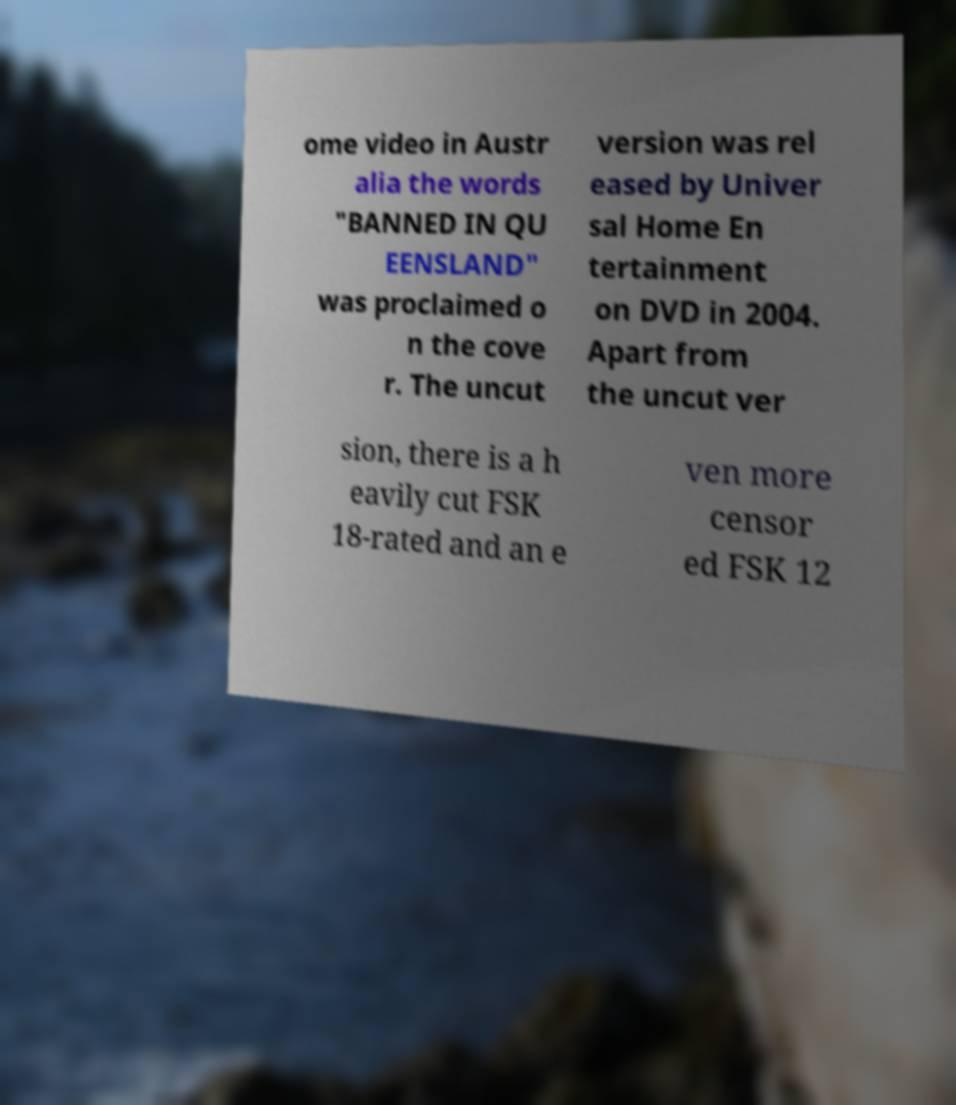There's text embedded in this image that I need extracted. Can you transcribe it verbatim? ome video in Austr alia the words "BANNED IN QU EENSLAND" was proclaimed o n the cove r. The uncut version was rel eased by Univer sal Home En tertainment on DVD in 2004. Apart from the uncut ver sion, there is a h eavily cut FSK 18-rated and an e ven more censor ed FSK 12 